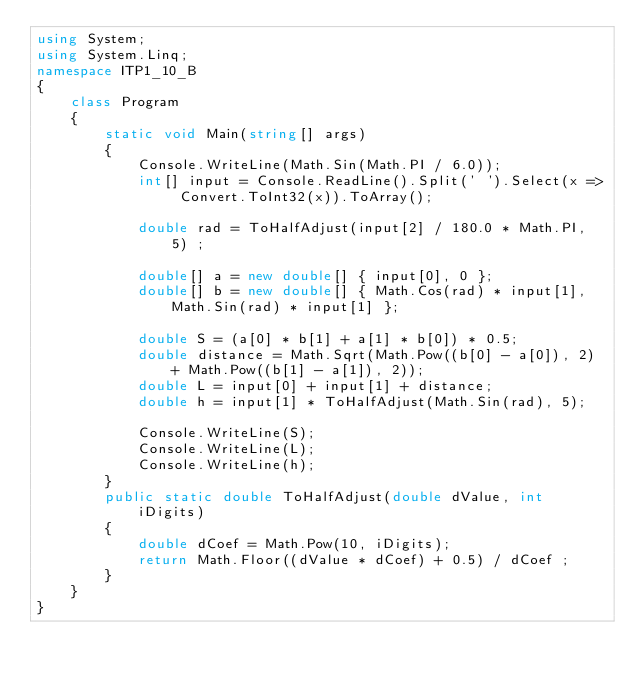Convert code to text. <code><loc_0><loc_0><loc_500><loc_500><_C#_>using System;
using System.Linq;
namespace ITP1_10_B
{
    class Program
    {
        static void Main(string[] args)
        {
            Console.WriteLine(Math.Sin(Math.PI / 6.0));
            int[] input = Console.ReadLine().Split(' ').Select(x => Convert.ToInt32(x)).ToArray();

            double rad = ToHalfAdjust(input[2] / 180.0 * Math.PI, 5) ;

            double[] a = new double[] { input[0], 0 };
            double[] b = new double[] { Math.Cos(rad) * input[1], Math.Sin(rad) * input[1] };

            double S = (a[0] * b[1] + a[1] * b[0]) * 0.5;
            double distance = Math.Sqrt(Math.Pow((b[0] - a[0]), 2) + Math.Pow((b[1] - a[1]), 2));
            double L = input[0] + input[1] + distance;
            double h = input[1] * ToHalfAdjust(Math.Sin(rad), 5);
    
            Console.WriteLine(S);
            Console.WriteLine(L);
            Console.WriteLine(h);
        }
        public static double ToHalfAdjust(double dValue, int iDigits)
        {
            double dCoef = Math.Pow(10, iDigits);
            return Math.Floor((dValue * dCoef) + 0.5) / dCoef ;
        }
    }
}</code> 